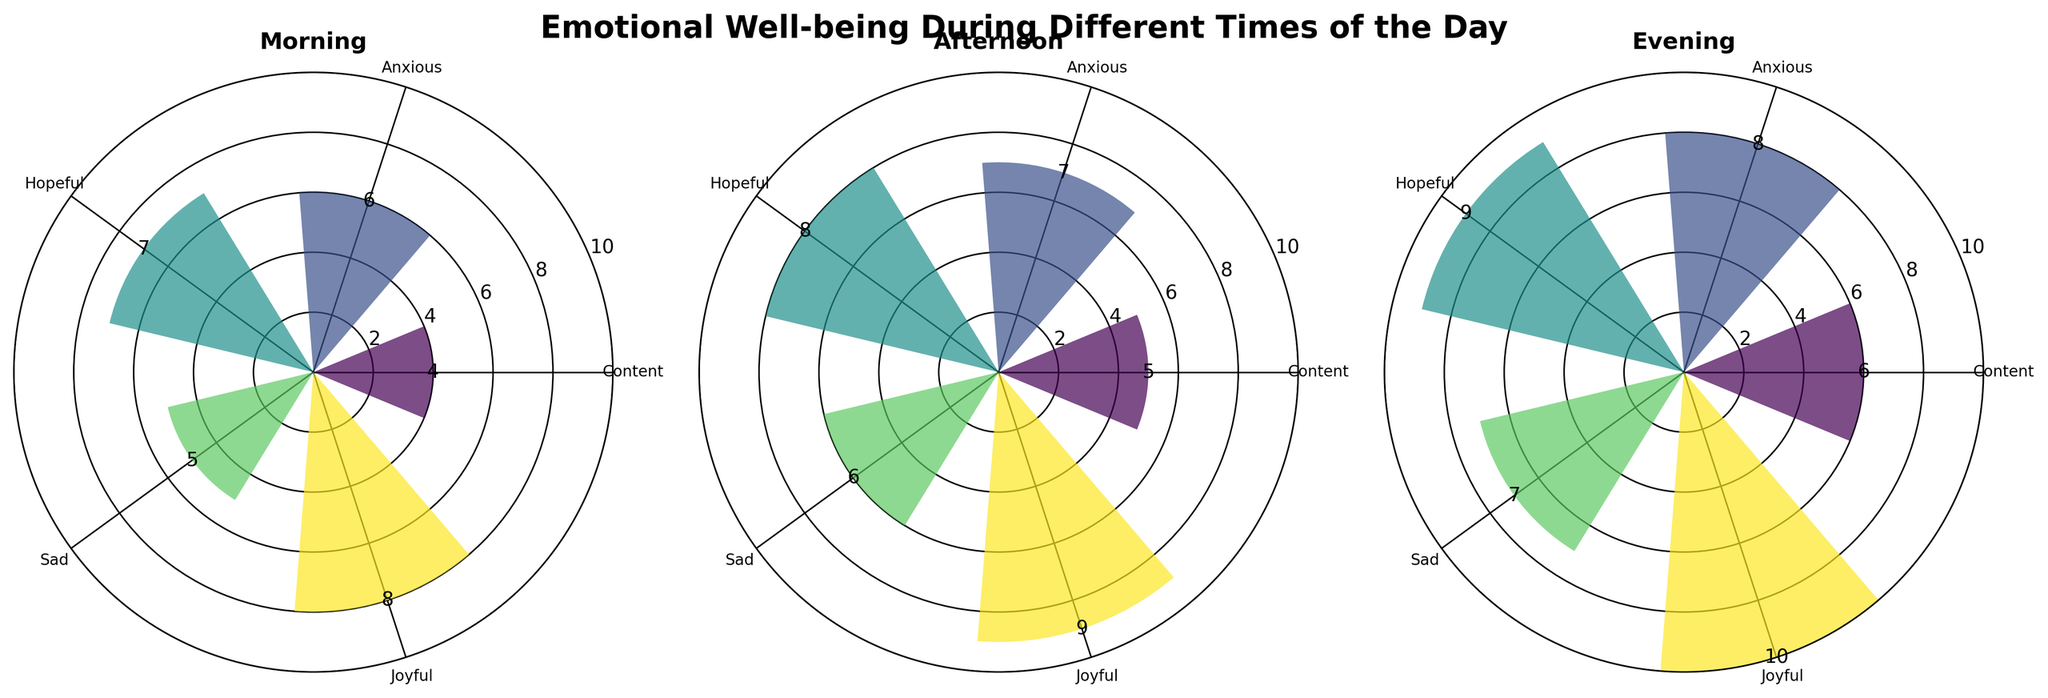What is the title of the figure? The title is located at the top of the figure and is in bold text. It reads "Emotional Well-being During Different Times of the Day".
Answer: Emotional Well-being During Different Times of the Day How many subplots are there in the figure? The figure is divided into multiple polar plots, which are distinguishable by their circular shape. Let's count them.
Answer: 3 Which emotion has the highest severity level in the Evening? Scan the Evening subplot and identify the emotion with the longest bar, which represents the highest severity level.
Answer: Joyful What is the total severity level for 'Hopeful' across all times of the day? Look at the severity levels for 'Hopeful' in each of the subplots and sum them: Morning (7), Afternoon (8), and Evening (9). 7 + 8 + 9 = 24.
Answer: 24 Compare the severity level of 'Anxious' in the Morning and Afternoon. Which one is higher? Compare the length of the 'Anxious' bar in the Morning subplot with the one in the Afternoon subplot to see which one extends further.
Answer: Afternoon Which treatment is associated with the highest severity level of 'Joyful' in the Afternoon? Look at the Afternoon subplot and identify the bar representing 'Joyful'. Then read the associated treatment from the data.
Answer: NeuroPlus How does the severity level of 'Sad' change from Morning to Evening? Observe the 'Sad' bars in both the Morning and Evening subplots. Note the numbers: Morning (5) and Evening (7). Calculate the difference: 7 - 5 = 2.
Answer: Increases by 2 What is the severity level of 'Content' in the Afternoon, and which treatment is it associated with? Locate the 'Content' bar in the Afternoon subplot and check its height for the severity level and the color coding for the treatment.
Answer: 5, NeuroEase Which time of day shows the highest overall (sum of all emotions) emotional well-being severity levels? Add the severity levels of all emotions for each time of day (Morning, Afternoon, Evening) and compare the sums.
Answer: Evening Which emotion shows the least variation in severity levels across different times of the day? Compare the bars across all subplots for each emotion and find the one that has the smallest difference between its minimum and maximum values.
Answer: Content 